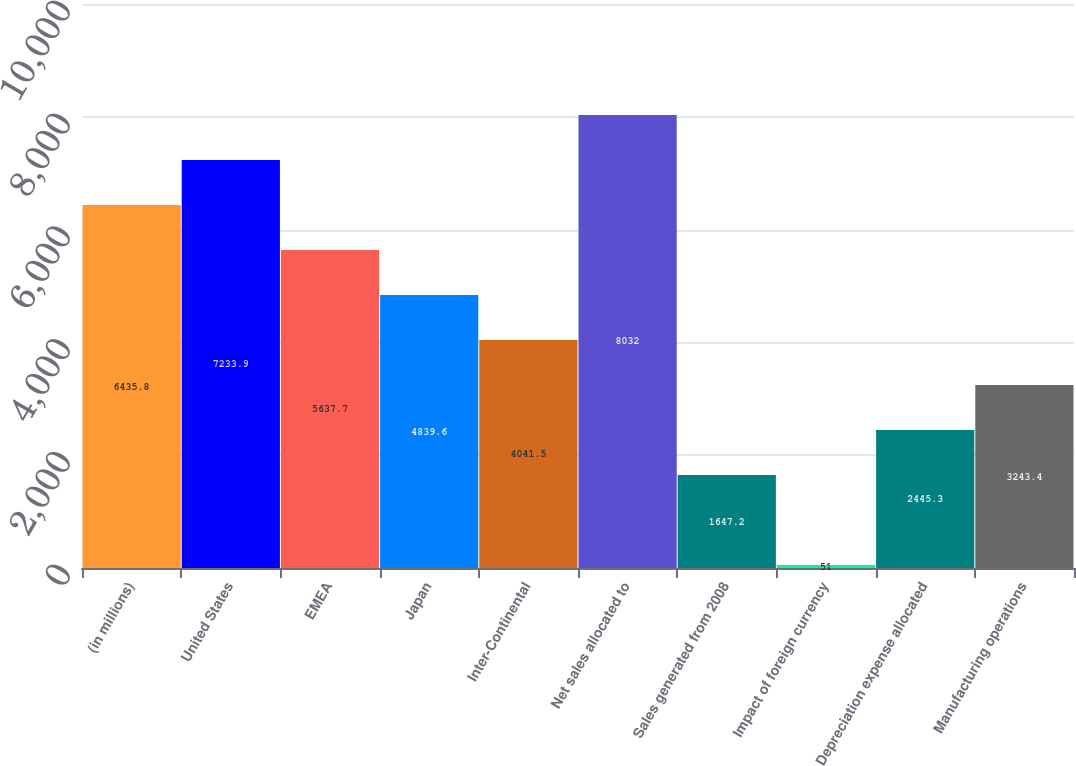<chart> <loc_0><loc_0><loc_500><loc_500><bar_chart><fcel>(in millions)<fcel>United States<fcel>EMEA<fcel>Japan<fcel>Inter-Continental<fcel>Net sales allocated to<fcel>Sales generated from 2008<fcel>Impact of foreign currency<fcel>Depreciation expense allocated<fcel>Manufacturing operations<nl><fcel>6435.8<fcel>7233.9<fcel>5637.7<fcel>4839.6<fcel>4041.5<fcel>8032<fcel>1647.2<fcel>51<fcel>2445.3<fcel>3243.4<nl></chart> 